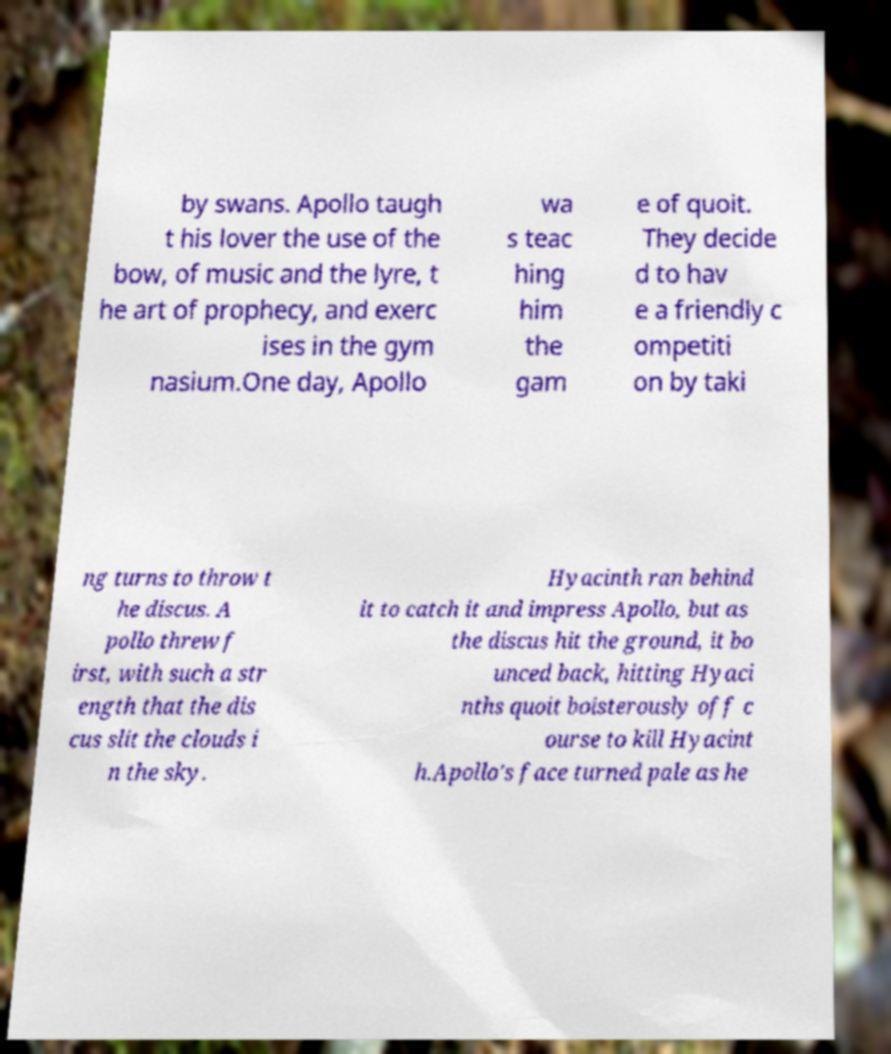I need the written content from this picture converted into text. Can you do that? by swans. Apollo taugh t his lover the use of the bow, of music and the lyre, t he art of prophecy, and exerc ises in the gym nasium.One day, Apollo wa s teac hing him the gam e of quoit. They decide d to hav e a friendly c ompetiti on by taki ng turns to throw t he discus. A pollo threw f irst, with such a str ength that the dis cus slit the clouds i n the sky. Hyacinth ran behind it to catch it and impress Apollo, but as the discus hit the ground, it bo unced back, hitting Hyaci nths quoit boisterously off c ourse to kill Hyacint h.Apollo's face turned pale as he 